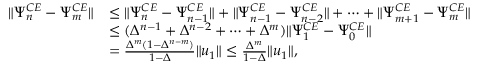<formula> <loc_0><loc_0><loc_500><loc_500>\begin{array} { r l } { \| \Psi _ { n } ^ { C E } - \Psi _ { m } ^ { C E } \| } & { \leq \| \Psi _ { n } ^ { C E } - \Psi _ { n - 1 } ^ { C E } \| + \| \Psi _ { n - 1 } ^ { C E } - \Psi _ { n - 2 } ^ { C E } \| + \cdots + \| \Psi _ { m + 1 } ^ { C E } - \Psi _ { m } ^ { C E } \| } \\ & { \leq ( \Delta ^ { n - 1 } + \Delta ^ { n - 2 } + \cdots + \Delta ^ { m } ) \| \Psi _ { 1 } ^ { C E } - \Psi _ { 0 } ^ { C E } \| } \\ & { = \frac { \Delta ^ { m } ( 1 - \Delta ^ { n - m } ) } { 1 - \Delta } \| u _ { 1 } \| \leq \frac { \Delta ^ { m } } { 1 - \Delta } \| u _ { 1 } \| , } \end{array}</formula> 